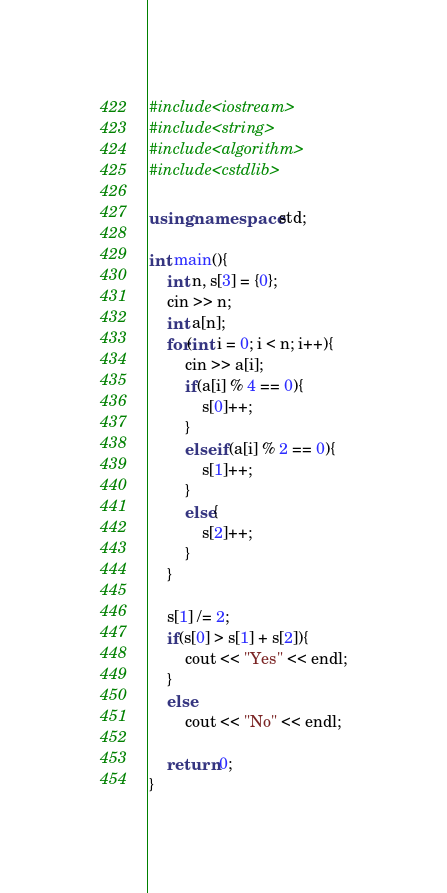Convert code to text. <code><loc_0><loc_0><loc_500><loc_500><_C++_>#include<iostream>
#include<string>
#include<algorithm>
#include<cstdlib>

using namespace std;

int main(){
	int n, s[3] = {0};
	cin >> n;
	int a[n];
	for(int i = 0; i < n; i++){
		cin >> a[i];
		if(a[i] % 4 == 0){
			s[0]++;
		}
		else if(a[i] % 2 == 0){
			s[1]++;
		}
		else{
			s[2]++;
		}
	}
	
	s[1] /= 2;
	if(s[0] > s[1] + s[2]){
		cout << "Yes" << endl;
	}
	else
		cout << "No" << endl;
	
 	return 0;
}</code> 